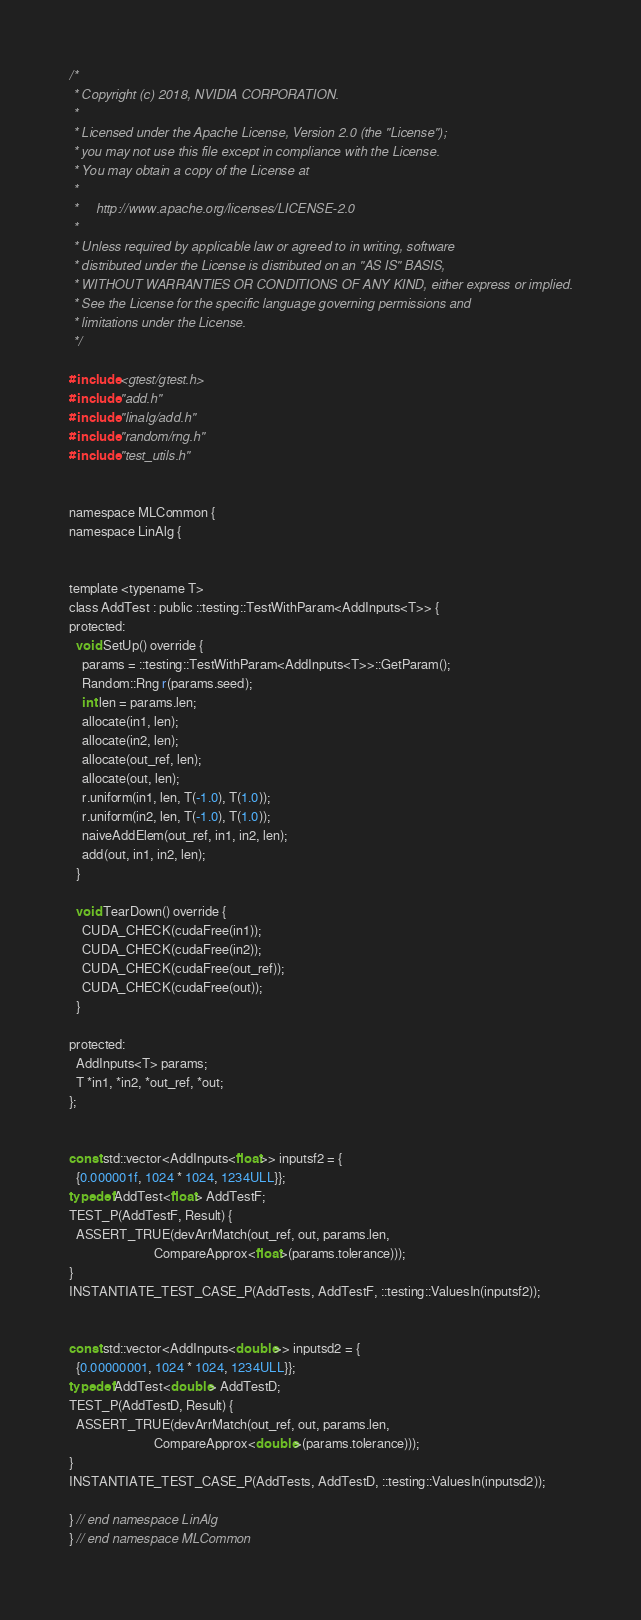Convert code to text. <code><loc_0><loc_0><loc_500><loc_500><_Cuda_>/*
 * Copyright (c) 2018, NVIDIA CORPORATION.
 *
 * Licensed under the Apache License, Version 2.0 (the "License");
 * you may not use this file except in compliance with the License.
 * You may obtain a copy of the License at
 *
 *     http://www.apache.org/licenses/LICENSE-2.0
 *
 * Unless required by applicable law or agreed to in writing, software
 * distributed under the License is distributed on an "AS IS" BASIS,
 * WITHOUT WARRANTIES OR CONDITIONS OF ANY KIND, either express or implied.
 * See the License for the specific language governing permissions and
 * limitations under the License.
 */

#include <gtest/gtest.h>
#include "add.h"
#include "linalg/add.h"
#include "random/rng.h"
#include "test_utils.h"


namespace MLCommon {
namespace LinAlg {


template <typename T>
class AddTest : public ::testing::TestWithParam<AddInputs<T>> {
protected:
  void SetUp() override {
    params = ::testing::TestWithParam<AddInputs<T>>::GetParam();
    Random::Rng r(params.seed);
    int len = params.len;
    allocate(in1, len);
    allocate(in2, len);
    allocate(out_ref, len);
    allocate(out, len);
    r.uniform(in1, len, T(-1.0), T(1.0));
    r.uniform(in2, len, T(-1.0), T(1.0));
    naiveAddElem(out_ref, in1, in2, len);
    add(out, in1, in2, len);
  }

  void TearDown() override {
    CUDA_CHECK(cudaFree(in1));
    CUDA_CHECK(cudaFree(in2));
    CUDA_CHECK(cudaFree(out_ref));
    CUDA_CHECK(cudaFree(out));
  }

protected:
  AddInputs<T> params;
  T *in1, *in2, *out_ref, *out;
};


const std::vector<AddInputs<float>> inputsf2 = {
  {0.000001f, 1024 * 1024, 1234ULL}};
typedef AddTest<float> AddTestF;
TEST_P(AddTestF, Result) {
  ASSERT_TRUE(devArrMatch(out_ref, out, params.len,
                          CompareApprox<float>(params.tolerance)));
}
INSTANTIATE_TEST_CASE_P(AddTests, AddTestF, ::testing::ValuesIn(inputsf2));


const std::vector<AddInputs<double>> inputsd2 = {
  {0.00000001, 1024 * 1024, 1234ULL}};
typedef AddTest<double> AddTestD;
TEST_P(AddTestD, Result) {
  ASSERT_TRUE(devArrMatch(out_ref, out, params.len,
                          CompareApprox<double>(params.tolerance)));
}
INSTANTIATE_TEST_CASE_P(AddTests, AddTestD, ::testing::ValuesIn(inputsd2));

} // end namespace LinAlg
} // end namespace MLCommon
</code> 